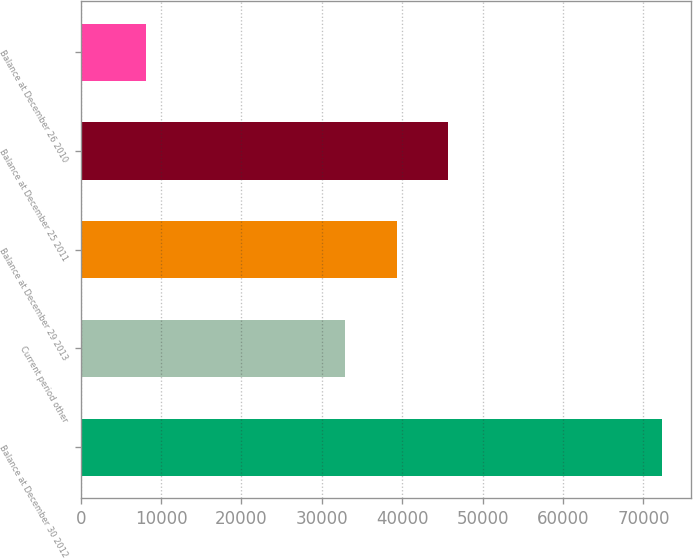Convert chart. <chart><loc_0><loc_0><loc_500><loc_500><bar_chart><fcel>Balance at December 30 2012<fcel>Current period other<fcel>Balance at December 29 2013<fcel>Balance at December 25 2011<fcel>Balance at December 26 2010<nl><fcel>72307<fcel>32902<fcel>39317.8<fcel>45733.6<fcel>8149<nl></chart> 